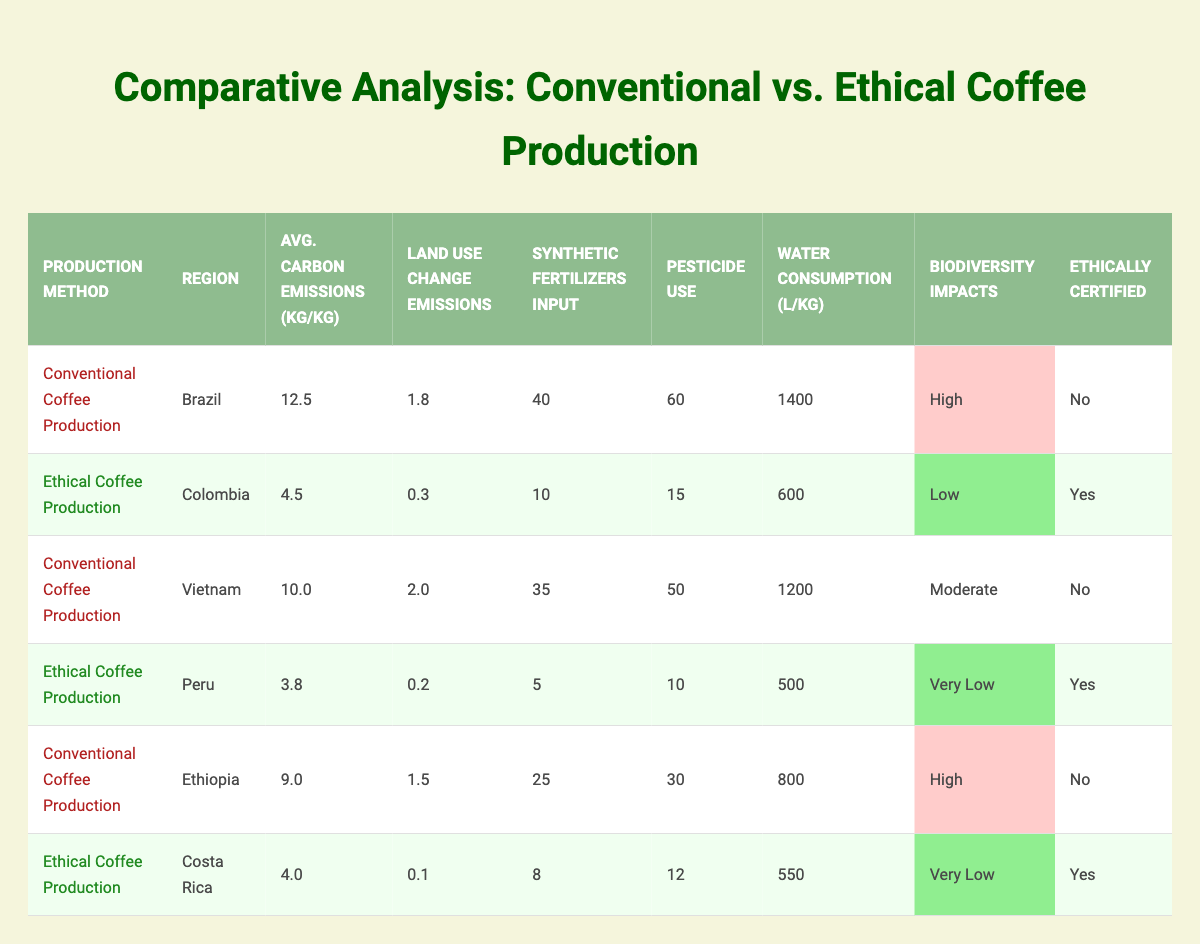What are the average carbon emissions per kg for ethical coffee production in Colombia? The table lists the average carbon emissions for ethical coffee production in Colombia as 4.5 kg/kg.
Answer: 4.5 kg/kg Which region shows the highest average carbon emissions per kg for conventional coffee production? The table shows Brazil with 12.5 kg/kg as the highest average carbon emissions per kg for conventional coffee production.
Answer: Brazil How many liters of water are consumed per kg of coffee produced in Peru? According to the table, the water consumption per kg of coffee produced in Peru is 500 liters.
Answer: 500 liters What is the difference in water consumption between conventional coffee production in Brazil and ethical coffee production in Colombia? Conventional coffee production in Brazil consumes 1400 liters, while ethical coffee production in Colombia consumes 600 liters. The difference is 1400 - 600 = 800 liters.
Answer: 800 liters Are all coffee production methods in Colombia certified as ethical? The table shows that only the ethical coffee production method in Colombia is certified, while conventional methods are not certified.
Answer: No How does the pesticide use in ethical coffee production in Costa Rica compare to that in conventional coffee production in Ethiopia? Ethical coffee production in Costa Rica uses 12 units of pesticides, while conventional coffee production in Ethiopia uses 30 units. Therefore, ethical coffee production uses 30 - 12 = 18 units less.
Answer: 18 units less What is the total average carbon emissions per kg for all ethical coffee production regions listed? The average carbon emissions for ethical production are 4.5 (Colombia) + 3.8 (Peru) + 4.0 (Costa Rica) = 12.3 kg/kg. Since there are three regions, the total average is 12.3 / 3 = 4.1 kg/kg.
Answer: 4.1 kg/kg In which region does ethical coffee production have the least impact on biodiversity? The table indicates that ethical coffee production in Peru has "Very Low" biodiversity impacts, which is the least among the regions listed.
Answer: Peru What is the total usage of synthetic fertilizers for conventional coffee production in Vietnam and Ethiopia combined? The usage of synthetic fertilizers in Vietnam is 35 and in Ethiopia is 25. The combined total is 35 + 25 = 60 units of synthetic fertilizers.
Answer: 60 units How many regions have ethical coffee production with low or very low biodiversity impacts? The table lists Colombia, Peru, and Costa Rica as regions with ethical coffee production, and both Peru and Costa Rica have very low biodiversity impacts while Colombia has low impacts. Thus, there are 3 regions combined with low biodiversity impacts.
Answer: 3 regions 